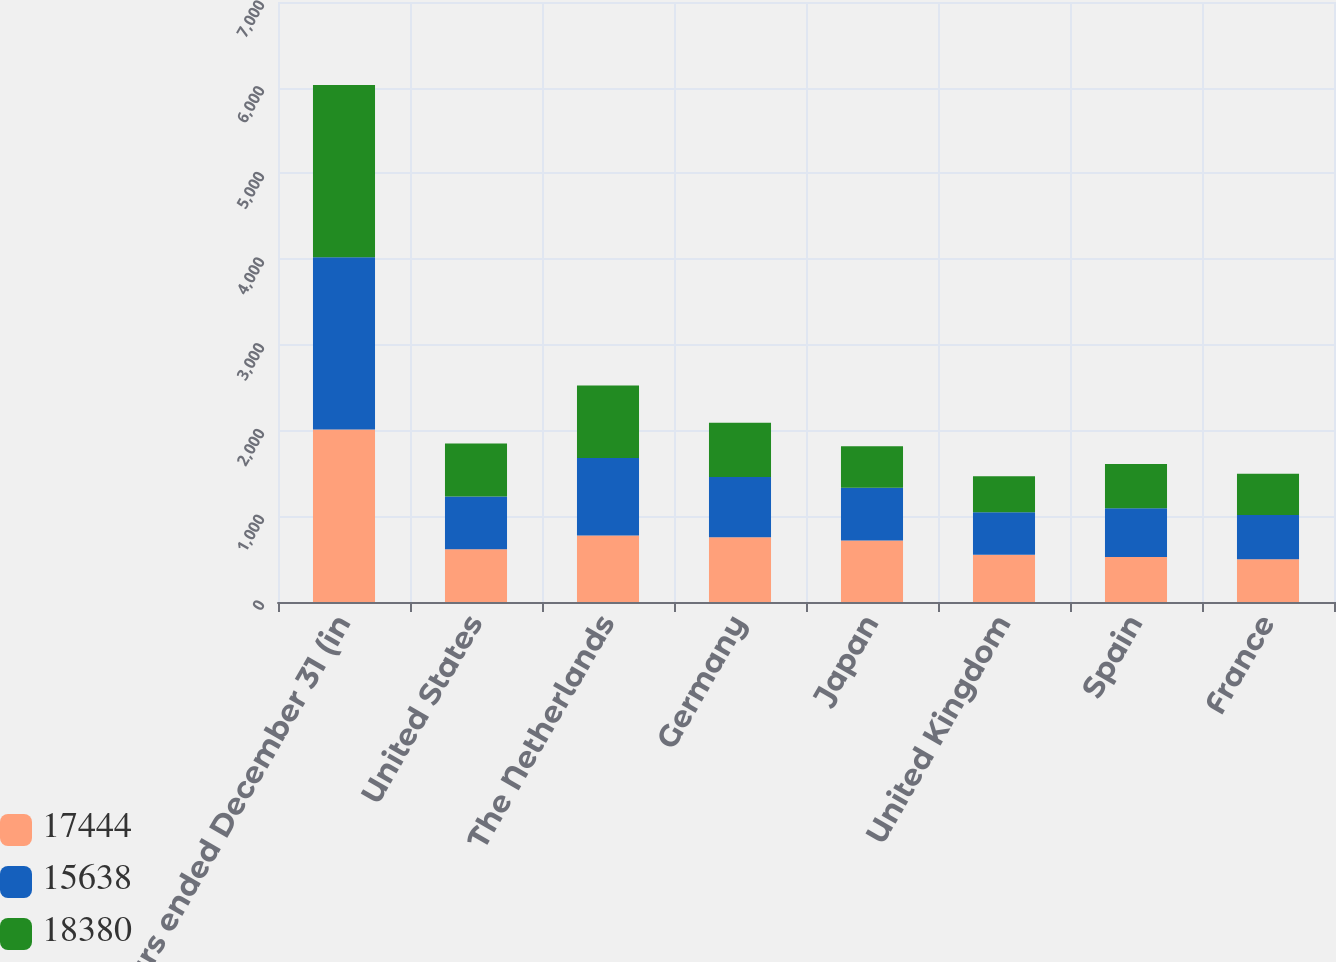<chart> <loc_0><loc_0><loc_500><loc_500><stacked_bar_chart><ecel><fcel>years ended December 31 (in<fcel>United States<fcel>The Netherlands<fcel>Germany<fcel>Japan<fcel>United Kingdom<fcel>Spain<fcel>France<nl><fcel>17444<fcel>2012<fcel>616<fcel>776<fcel>756<fcel>718<fcel>552<fcel>525<fcel>500<nl><fcel>15638<fcel>2011<fcel>616<fcel>904<fcel>701<fcel>616<fcel>496<fcel>569<fcel>516<nl><fcel>18380<fcel>2010<fcel>616<fcel>845<fcel>635<fcel>484<fcel>418<fcel>515<fcel>479<nl></chart> 